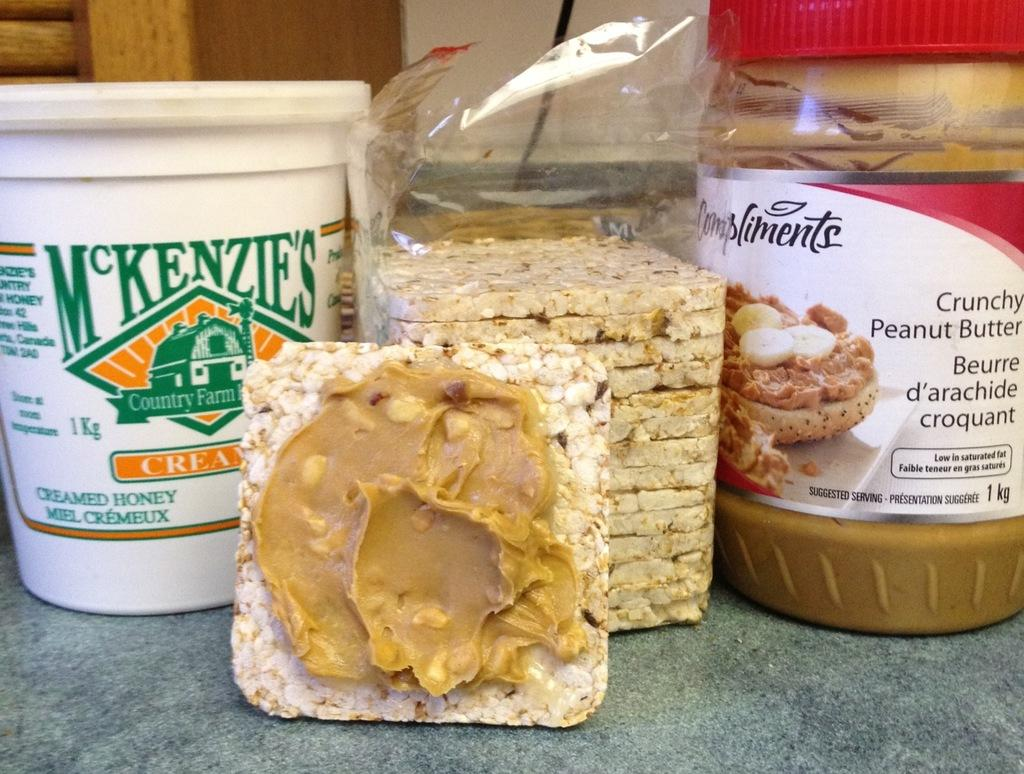What type of food is featured in the cover of the image? There are peanut bars in the cover. Can you describe the specific type of peanut bar in the image? There is a peanut bar with peanut butter. How many plastic containers are visible in the image? There are two plastic containers. What colors can be seen in the background of the image? The background has a brown and cream color. How many apples are present in the image? There are no apples visible in the image. What type of flock can be seen flying in the background of the image? There is no flock present in the image; the background consists of a brown and cream color. 